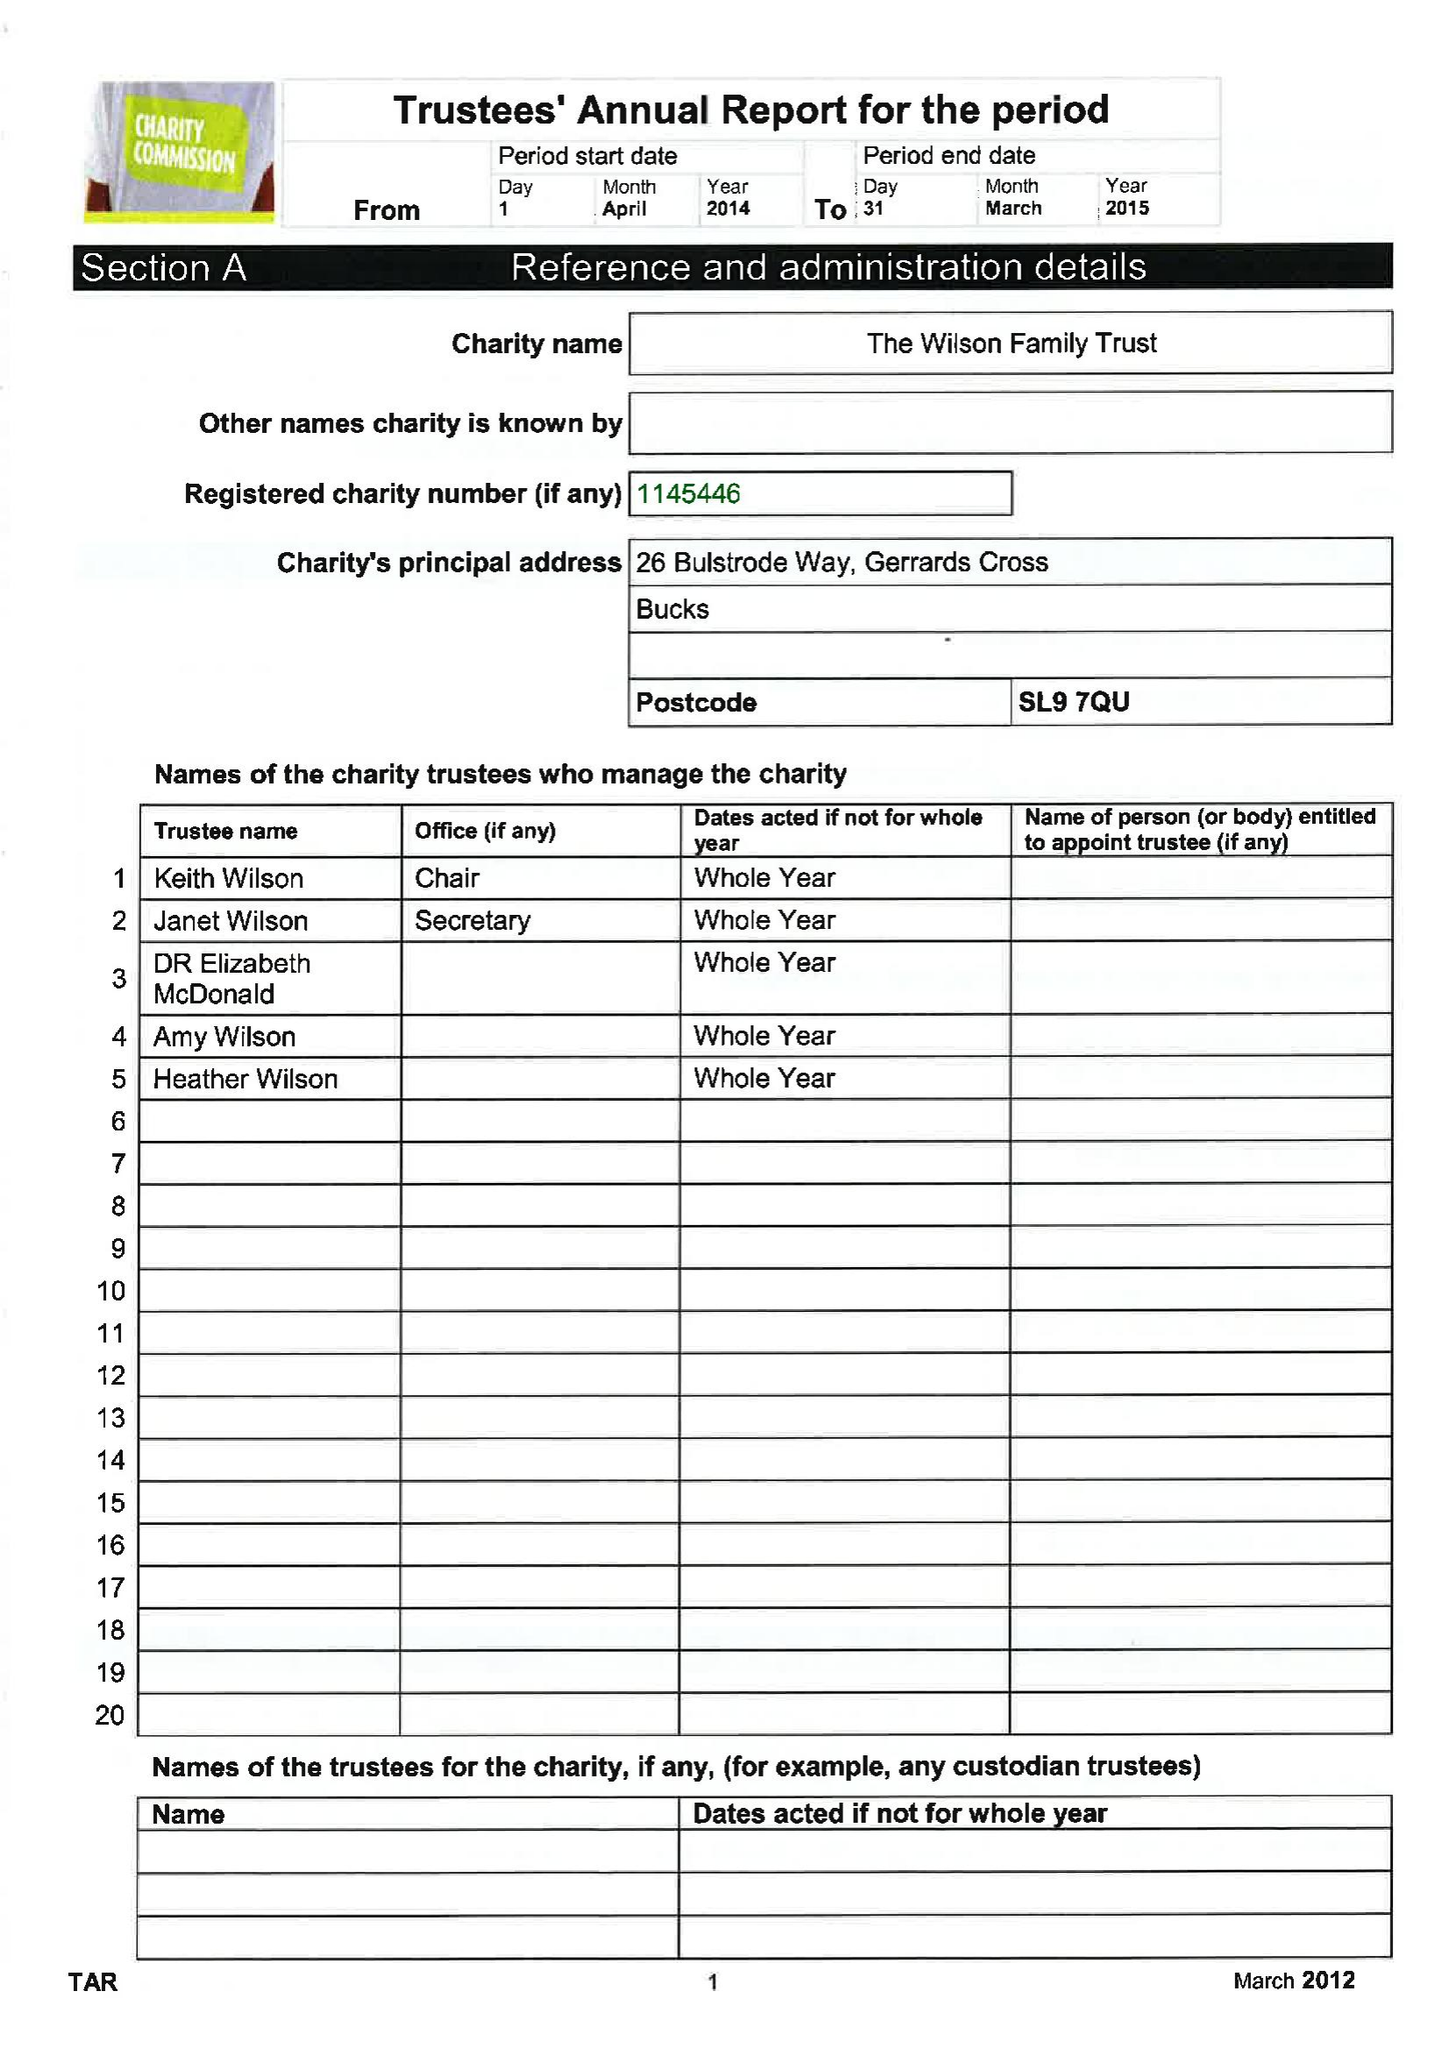What is the value for the income_annually_in_british_pounds?
Answer the question using a single word or phrase. 76926.00 